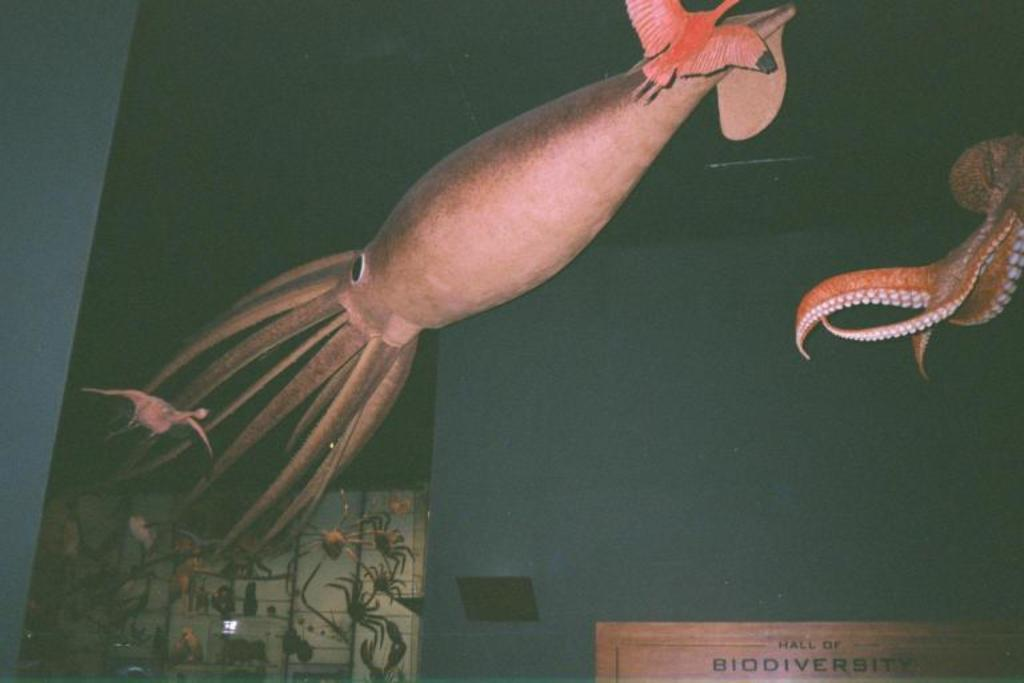What animal is located on the right side of the image? There is an octopus on the right side of the image. What is the object at the right bottom of the image? There is a board at the right bottom of the image. What type of creatures can be seen in the image besides the octopus? There are insects visible in the image. What object resembles a fish in the image? There is an object that looks like a fish in the image. What type of drug can be seen in the image? There is no drug present in the image. Can you see a squirrel running across the road in the image? There is no squirrel or road present in the image. 